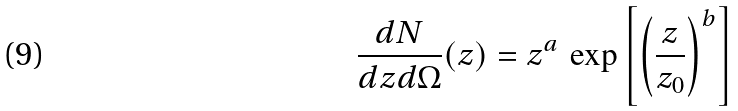<formula> <loc_0><loc_0><loc_500><loc_500>\frac { d N } { d z d \Omega } ( z ) = z ^ { a } \, \exp \left [ \left ( \frac { z } { z _ { 0 } } \right ) ^ { b } \right ]</formula> 